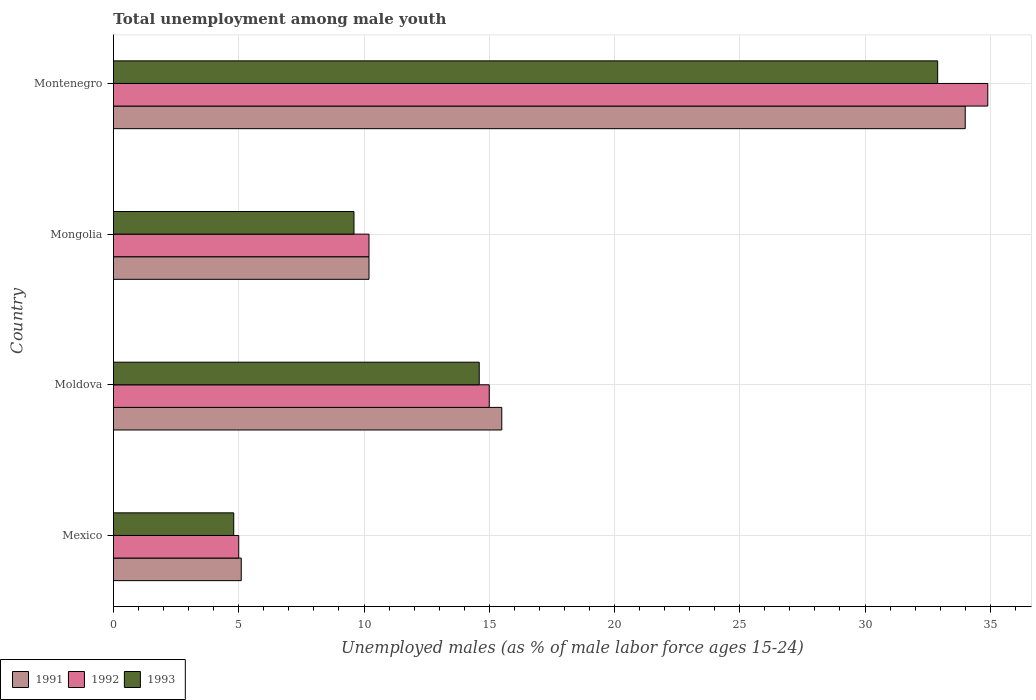How many groups of bars are there?
Make the answer very short. 4. Are the number of bars per tick equal to the number of legend labels?
Your answer should be compact. Yes. Are the number of bars on each tick of the Y-axis equal?
Offer a very short reply. Yes. How many bars are there on the 3rd tick from the top?
Your answer should be very brief. 3. What is the percentage of unemployed males in in 1992 in Montenegro?
Your answer should be very brief. 34.9. Across all countries, what is the maximum percentage of unemployed males in in 1992?
Make the answer very short. 34.9. In which country was the percentage of unemployed males in in 1991 maximum?
Your answer should be compact. Montenegro. What is the total percentage of unemployed males in in 1992 in the graph?
Your answer should be very brief. 65.1. What is the difference between the percentage of unemployed males in in 1991 in Mexico and that in Moldova?
Your answer should be compact. -10.4. What is the difference between the percentage of unemployed males in in 1992 in Mongolia and the percentage of unemployed males in in 1991 in Montenegro?
Make the answer very short. -23.8. What is the average percentage of unemployed males in in 1991 per country?
Your response must be concise. 16.2. What is the difference between the percentage of unemployed males in in 1993 and percentage of unemployed males in in 1991 in Mongolia?
Provide a succinct answer. -0.6. In how many countries, is the percentage of unemployed males in in 1991 greater than 8 %?
Provide a short and direct response. 3. What is the ratio of the percentage of unemployed males in in 1993 in Mongolia to that in Montenegro?
Provide a short and direct response. 0.29. Is the difference between the percentage of unemployed males in in 1993 in Mexico and Moldova greater than the difference between the percentage of unemployed males in in 1991 in Mexico and Moldova?
Keep it short and to the point. Yes. What is the difference between the highest and the lowest percentage of unemployed males in in 1991?
Your answer should be compact. 28.9. In how many countries, is the percentage of unemployed males in in 1992 greater than the average percentage of unemployed males in in 1992 taken over all countries?
Your answer should be compact. 1. Is the sum of the percentage of unemployed males in in 1991 in Mongolia and Montenegro greater than the maximum percentage of unemployed males in in 1992 across all countries?
Keep it short and to the point. Yes. Are all the bars in the graph horizontal?
Give a very brief answer. Yes. How many countries are there in the graph?
Provide a short and direct response. 4. Are the values on the major ticks of X-axis written in scientific E-notation?
Keep it short and to the point. No. Does the graph contain any zero values?
Your response must be concise. No. How many legend labels are there?
Offer a very short reply. 3. What is the title of the graph?
Your answer should be compact. Total unemployment among male youth. What is the label or title of the X-axis?
Give a very brief answer. Unemployed males (as % of male labor force ages 15-24). What is the label or title of the Y-axis?
Provide a short and direct response. Country. What is the Unemployed males (as % of male labor force ages 15-24) in 1991 in Mexico?
Your response must be concise. 5.1. What is the Unemployed males (as % of male labor force ages 15-24) of 1993 in Mexico?
Your answer should be compact. 4.8. What is the Unemployed males (as % of male labor force ages 15-24) of 1991 in Moldova?
Your answer should be compact. 15.5. What is the Unemployed males (as % of male labor force ages 15-24) in 1993 in Moldova?
Make the answer very short. 14.6. What is the Unemployed males (as % of male labor force ages 15-24) in 1991 in Mongolia?
Make the answer very short. 10.2. What is the Unemployed males (as % of male labor force ages 15-24) in 1992 in Mongolia?
Keep it short and to the point. 10.2. What is the Unemployed males (as % of male labor force ages 15-24) of 1993 in Mongolia?
Ensure brevity in your answer.  9.6. What is the Unemployed males (as % of male labor force ages 15-24) in 1992 in Montenegro?
Provide a succinct answer. 34.9. What is the Unemployed males (as % of male labor force ages 15-24) of 1993 in Montenegro?
Provide a short and direct response. 32.9. Across all countries, what is the maximum Unemployed males (as % of male labor force ages 15-24) in 1992?
Your response must be concise. 34.9. Across all countries, what is the maximum Unemployed males (as % of male labor force ages 15-24) of 1993?
Keep it short and to the point. 32.9. Across all countries, what is the minimum Unemployed males (as % of male labor force ages 15-24) of 1991?
Make the answer very short. 5.1. Across all countries, what is the minimum Unemployed males (as % of male labor force ages 15-24) of 1993?
Ensure brevity in your answer.  4.8. What is the total Unemployed males (as % of male labor force ages 15-24) in 1991 in the graph?
Your response must be concise. 64.8. What is the total Unemployed males (as % of male labor force ages 15-24) in 1992 in the graph?
Your response must be concise. 65.1. What is the total Unemployed males (as % of male labor force ages 15-24) of 1993 in the graph?
Keep it short and to the point. 61.9. What is the difference between the Unemployed males (as % of male labor force ages 15-24) in 1993 in Mexico and that in Mongolia?
Your answer should be compact. -4.8. What is the difference between the Unemployed males (as % of male labor force ages 15-24) of 1991 in Mexico and that in Montenegro?
Your response must be concise. -28.9. What is the difference between the Unemployed males (as % of male labor force ages 15-24) in 1992 in Mexico and that in Montenegro?
Make the answer very short. -29.9. What is the difference between the Unemployed males (as % of male labor force ages 15-24) of 1993 in Mexico and that in Montenegro?
Provide a short and direct response. -28.1. What is the difference between the Unemployed males (as % of male labor force ages 15-24) in 1991 in Moldova and that in Mongolia?
Your answer should be compact. 5.3. What is the difference between the Unemployed males (as % of male labor force ages 15-24) in 1993 in Moldova and that in Mongolia?
Your answer should be very brief. 5. What is the difference between the Unemployed males (as % of male labor force ages 15-24) of 1991 in Moldova and that in Montenegro?
Make the answer very short. -18.5. What is the difference between the Unemployed males (as % of male labor force ages 15-24) in 1992 in Moldova and that in Montenegro?
Give a very brief answer. -19.9. What is the difference between the Unemployed males (as % of male labor force ages 15-24) in 1993 in Moldova and that in Montenegro?
Keep it short and to the point. -18.3. What is the difference between the Unemployed males (as % of male labor force ages 15-24) in 1991 in Mongolia and that in Montenegro?
Offer a terse response. -23.8. What is the difference between the Unemployed males (as % of male labor force ages 15-24) of 1992 in Mongolia and that in Montenegro?
Your response must be concise. -24.7. What is the difference between the Unemployed males (as % of male labor force ages 15-24) in 1993 in Mongolia and that in Montenegro?
Your answer should be compact. -23.3. What is the difference between the Unemployed males (as % of male labor force ages 15-24) of 1991 in Mexico and the Unemployed males (as % of male labor force ages 15-24) of 1992 in Moldova?
Your answer should be very brief. -9.9. What is the difference between the Unemployed males (as % of male labor force ages 15-24) in 1991 in Mexico and the Unemployed males (as % of male labor force ages 15-24) in 1993 in Moldova?
Your answer should be compact. -9.5. What is the difference between the Unemployed males (as % of male labor force ages 15-24) in 1991 in Mexico and the Unemployed males (as % of male labor force ages 15-24) in 1992 in Mongolia?
Make the answer very short. -5.1. What is the difference between the Unemployed males (as % of male labor force ages 15-24) of 1992 in Mexico and the Unemployed males (as % of male labor force ages 15-24) of 1993 in Mongolia?
Offer a terse response. -4.6. What is the difference between the Unemployed males (as % of male labor force ages 15-24) of 1991 in Mexico and the Unemployed males (as % of male labor force ages 15-24) of 1992 in Montenegro?
Your answer should be compact. -29.8. What is the difference between the Unemployed males (as % of male labor force ages 15-24) of 1991 in Mexico and the Unemployed males (as % of male labor force ages 15-24) of 1993 in Montenegro?
Give a very brief answer. -27.8. What is the difference between the Unemployed males (as % of male labor force ages 15-24) in 1992 in Mexico and the Unemployed males (as % of male labor force ages 15-24) in 1993 in Montenegro?
Ensure brevity in your answer.  -27.9. What is the difference between the Unemployed males (as % of male labor force ages 15-24) in 1992 in Moldova and the Unemployed males (as % of male labor force ages 15-24) in 1993 in Mongolia?
Ensure brevity in your answer.  5.4. What is the difference between the Unemployed males (as % of male labor force ages 15-24) of 1991 in Moldova and the Unemployed males (as % of male labor force ages 15-24) of 1992 in Montenegro?
Your answer should be very brief. -19.4. What is the difference between the Unemployed males (as % of male labor force ages 15-24) in 1991 in Moldova and the Unemployed males (as % of male labor force ages 15-24) in 1993 in Montenegro?
Make the answer very short. -17.4. What is the difference between the Unemployed males (as % of male labor force ages 15-24) in 1992 in Moldova and the Unemployed males (as % of male labor force ages 15-24) in 1993 in Montenegro?
Provide a short and direct response. -17.9. What is the difference between the Unemployed males (as % of male labor force ages 15-24) of 1991 in Mongolia and the Unemployed males (as % of male labor force ages 15-24) of 1992 in Montenegro?
Provide a succinct answer. -24.7. What is the difference between the Unemployed males (as % of male labor force ages 15-24) in 1991 in Mongolia and the Unemployed males (as % of male labor force ages 15-24) in 1993 in Montenegro?
Your answer should be very brief. -22.7. What is the difference between the Unemployed males (as % of male labor force ages 15-24) in 1992 in Mongolia and the Unemployed males (as % of male labor force ages 15-24) in 1993 in Montenegro?
Make the answer very short. -22.7. What is the average Unemployed males (as % of male labor force ages 15-24) of 1992 per country?
Your answer should be compact. 16.27. What is the average Unemployed males (as % of male labor force ages 15-24) of 1993 per country?
Ensure brevity in your answer.  15.47. What is the difference between the Unemployed males (as % of male labor force ages 15-24) in 1991 and Unemployed males (as % of male labor force ages 15-24) in 1993 in Mexico?
Ensure brevity in your answer.  0.3. What is the difference between the Unemployed males (as % of male labor force ages 15-24) in 1992 and Unemployed males (as % of male labor force ages 15-24) in 1993 in Mexico?
Ensure brevity in your answer.  0.2. What is the difference between the Unemployed males (as % of male labor force ages 15-24) in 1991 and Unemployed males (as % of male labor force ages 15-24) in 1992 in Moldova?
Your answer should be very brief. 0.5. What is the difference between the Unemployed males (as % of male labor force ages 15-24) of 1991 and Unemployed males (as % of male labor force ages 15-24) of 1993 in Moldova?
Your answer should be compact. 0.9. What is the difference between the Unemployed males (as % of male labor force ages 15-24) in 1992 and Unemployed males (as % of male labor force ages 15-24) in 1993 in Mongolia?
Your response must be concise. 0.6. What is the difference between the Unemployed males (as % of male labor force ages 15-24) of 1991 and Unemployed males (as % of male labor force ages 15-24) of 1992 in Montenegro?
Provide a succinct answer. -0.9. What is the ratio of the Unemployed males (as % of male labor force ages 15-24) in 1991 in Mexico to that in Moldova?
Offer a terse response. 0.33. What is the ratio of the Unemployed males (as % of male labor force ages 15-24) in 1992 in Mexico to that in Moldova?
Your response must be concise. 0.33. What is the ratio of the Unemployed males (as % of male labor force ages 15-24) of 1993 in Mexico to that in Moldova?
Keep it short and to the point. 0.33. What is the ratio of the Unemployed males (as % of male labor force ages 15-24) of 1991 in Mexico to that in Mongolia?
Offer a terse response. 0.5. What is the ratio of the Unemployed males (as % of male labor force ages 15-24) of 1992 in Mexico to that in Mongolia?
Provide a succinct answer. 0.49. What is the ratio of the Unemployed males (as % of male labor force ages 15-24) in 1993 in Mexico to that in Mongolia?
Keep it short and to the point. 0.5. What is the ratio of the Unemployed males (as % of male labor force ages 15-24) of 1992 in Mexico to that in Montenegro?
Ensure brevity in your answer.  0.14. What is the ratio of the Unemployed males (as % of male labor force ages 15-24) of 1993 in Mexico to that in Montenegro?
Provide a succinct answer. 0.15. What is the ratio of the Unemployed males (as % of male labor force ages 15-24) in 1991 in Moldova to that in Mongolia?
Provide a succinct answer. 1.52. What is the ratio of the Unemployed males (as % of male labor force ages 15-24) in 1992 in Moldova to that in Mongolia?
Your response must be concise. 1.47. What is the ratio of the Unemployed males (as % of male labor force ages 15-24) in 1993 in Moldova to that in Mongolia?
Your response must be concise. 1.52. What is the ratio of the Unemployed males (as % of male labor force ages 15-24) in 1991 in Moldova to that in Montenegro?
Provide a short and direct response. 0.46. What is the ratio of the Unemployed males (as % of male labor force ages 15-24) of 1992 in Moldova to that in Montenegro?
Provide a succinct answer. 0.43. What is the ratio of the Unemployed males (as % of male labor force ages 15-24) of 1993 in Moldova to that in Montenegro?
Provide a succinct answer. 0.44. What is the ratio of the Unemployed males (as % of male labor force ages 15-24) of 1991 in Mongolia to that in Montenegro?
Give a very brief answer. 0.3. What is the ratio of the Unemployed males (as % of male labor force ages 15-24) of 1992 in Mongolia to that in Montenegro?
Your response must be concise. 0.29. What is the ratio of the Unemployed males (as % of male labor force ages 15-24) in 1993 in Mongolia to that in Montenegro?
Provide a short and direct response. 0.29. What is the difference between the highest and the lowest Unemployed males (as % of male labor force ages 15-24) in 1991?
Keep it short and to the point. 28.9. What is the difference between the highest and the lowest Unemployed males (as % of male labor force ages 15-24) in 1992?
Your answer should be compact. 29.9. What is the difference between the highest and the lowest Unemployed males (as % of male labor force ages 15-24) of 1993?
Your response must be concise. 28.1. 